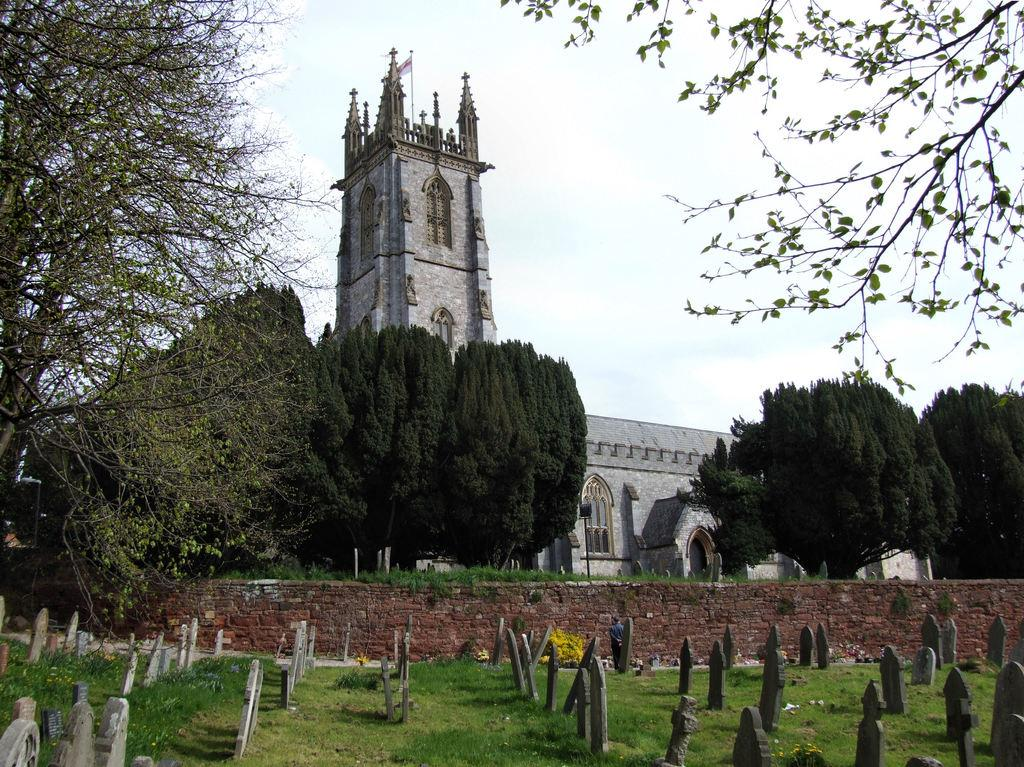What type of structures can be seen in the image? There are graves, a wall, trees, and a building with windows in the image. Can you describe the building in the image? The building has windows and is located near the graves and wall. What is visible in the background of the image? The sky with clouds is visible in the background of the image. Can you tell me how many squirrels are climbing on the trees in the image? There are no squirrels present in the image; it only features graves, a wall, trees, a building, and the sky with clouds. 